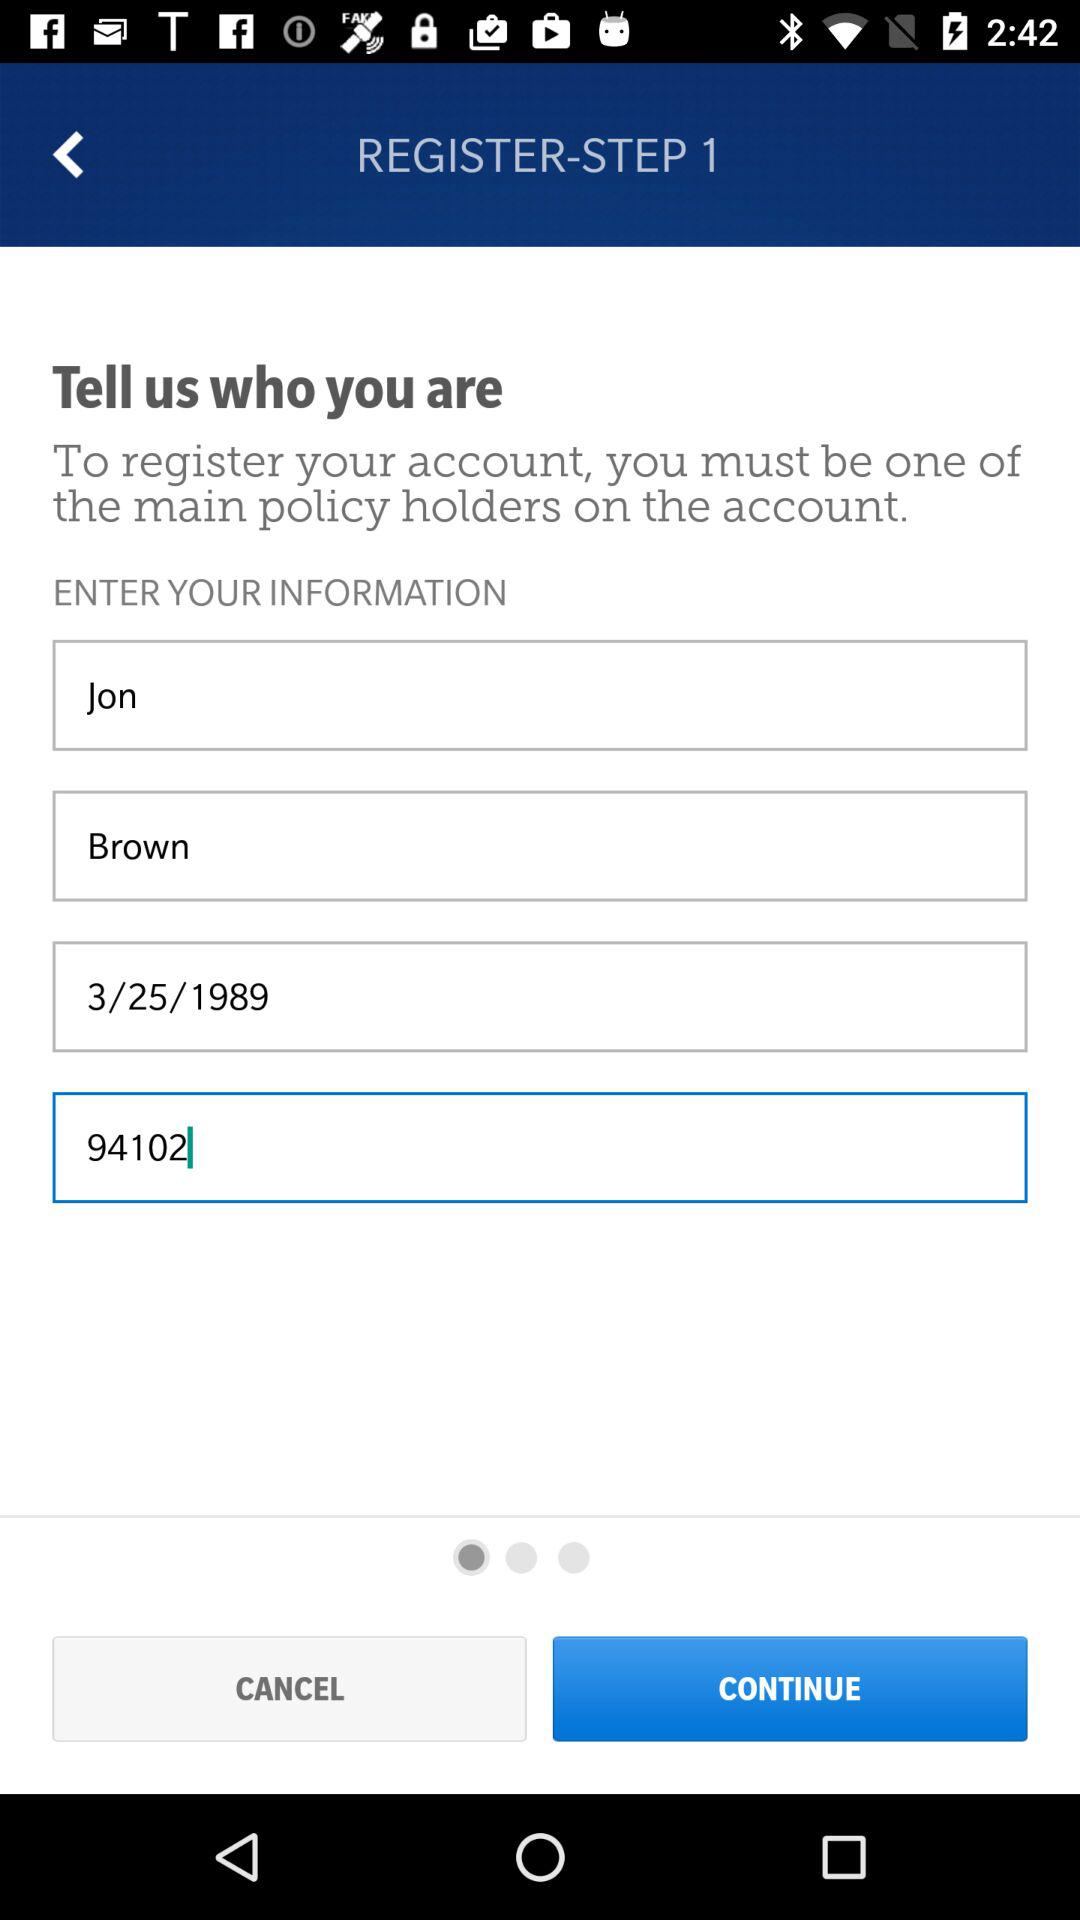What is the date of birth? The date of birth is 3/25/1989. 